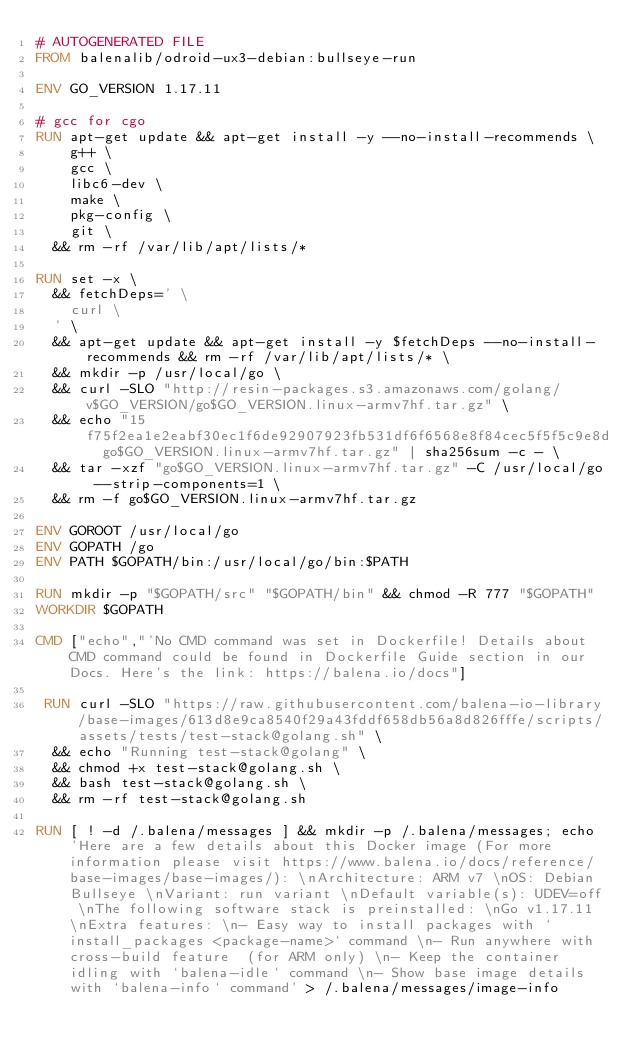Convert code to text. <code><loc_0><loc_0><loc_500><loc_500><_Dockerfile_># AUTOGENERATED FILE
FROM balenalib/odroid-ux3-debian:bullseye-run

ENV GO_VERSION 1.17.11

# gcc for cgo
RUN apt-get update && apt-get install -y --no-install-recommends \
		g++ \
		gcc \
		libc6-dev \
		make \
		pkg-config \
		git \
	&& rm -rf /var/lib/apt/lists/*

RUN set -x \
	&& fetchDeps=' \
		curl \
	' \
	&& apt-get update && apt-get install -y $fetchDeps --no-install-recommends && rm -rf /var/lib/apt/lists/* \
	&& mkdir -p /usr/local/go \
	&& curl -SLO "http://resin-packages.s3.amazonaws.com/golang/v$GO_VERSION/go$GO_VERSION.linux-armv7hf.tar.gz" \
	&& echo "15f75f2ea1e2eabf30ec1f6de92907923fb531df6f6568e8f84cec5f5f5c9e8d  go$GO_VERSION.linux-armv7hf.tar.gz" | sha256sum -c - \
	&& tar -xzf "go$GO_VERSION.linux-armv7hf.tar.gz" -C /usr/local/go --strip-components=1 \
	&& rm -f go$GO_VERSION.linux-armv7hf.tar.gz

ENV GOROOT /usr/local/go
ENV GOPATH /go
ENV PATH $GOPATH/bin:/usr/local/go/bin:$PATH

RUN mkdir -p "$GOPATH/src" "$GOPATH/bin" && chmod -R 777 "$GOPATH"
WORKDIR $GOPATH

CMD ["echo","'No CMD command was set in Dockerfile! Details about CMD command could be found in Dockerfile Guide section in our Docs. Here's the link: https://balena.io/docs"]

 RUN curl -SLO "https://raw.githubusercontent.com/balena-io-library/base-images/613d8e9ca8540f29a43fddf658db56a8d826fffe/scripts/assets/tests/test-stack@golang.sh" \
  && echo "Running test-stack@golang" \
  && chmod +x test-stack@golang.sh \
  && bash test-stack@golang.sh \
  && rm -rf test-stack@golang.sh 

RUN [ ! -d /.balena/messages ] && mkdir -p /.balena/messages; echo 'Here are a few details about this Docker image (For more information please visit https://www.balena.io/docs/reference/base-images/base-images/): \nArchitecture: ARM v7 \nOS: Debian Bullseye \nVariant: run variant \nDefault variable(s): UDEV=off \nThe following software stack is preinstalled: \nGo v1.17.11 \nExtra features: \n- Easy way to install packages with `install_packages <package-name>` command \n- Run anywhere with cross-build feature  (for ARM only) \n- Keep the container idling with `balena-idle` command \n- Show base image details with `balena-info` command' > /.balena/messages/image-info</code> 